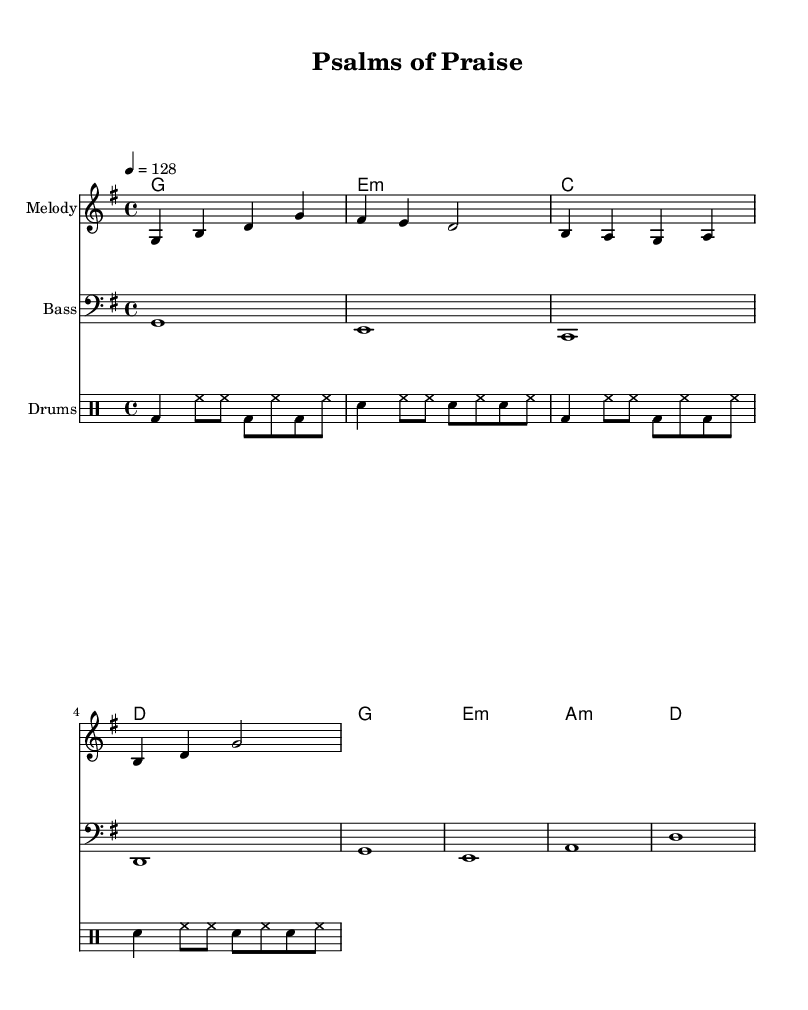What is the key signature of this music? The key signature is G major, which has one sharp (F#).
Answer: G major What is the time signature of this music? The time signature is 4/4, indicating four beats per measure with each beat as a quarter note.
Answer: 4/4 What is the tempo marking? The tempo marking indicates a speed of 128 beats per minute, specifying how fast the piece should be played.
Answer: 128 How many measures are in the melody section? The melody section contains four measures based on the provided notation of the notes and their division.
Answer: Four What is the primary chord used throughout the piece? The primary chord is G major, which appears consistently across different sections, establishing the tonal center.
Answer: G major Why does the bass line end on G? The bass line concludes on G, which is the root of the key, providing a sense of resolution and fullness to the overall harmonic structure.
Answer: G What is the role of the drums in this contemporary Christian dance music? The drums provide a rhythmic foundation that drives the piece forward, emphasizing the danceable nature of the music while supporting the other instruments.
Answer: Drive 